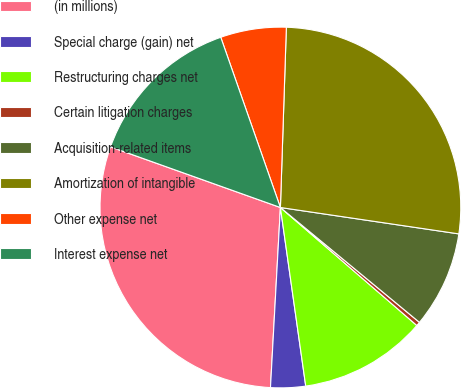<chart> <loc_0><loc_0><loc_500><loc_500><pie_chart><fcel>(in millions)<fcel>Special charge (gain) net<fcel>Restructuring charges net<fcel>Certain litigation charges<fcel>Acquisition-related items<fcel>Amortization of intangible<fcel>Other expense net<fcel>Interest expense net<nl><fcel>29.58%<fcel>3.12%<fcel>11.41%<fcel>0.36%<fcel>8.65%<fcel>26.81%<fcel>5.89%<fcel>14.18%<nl></chart> 